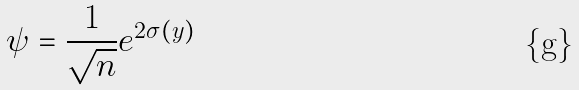Convert formula to latex. <formula><loc_0><loc_0><loc_500><loc_500>\psi = \frac { 1 } { \sqrt { n } } e ^ { 2 \sigma ( y ) }</formula> 